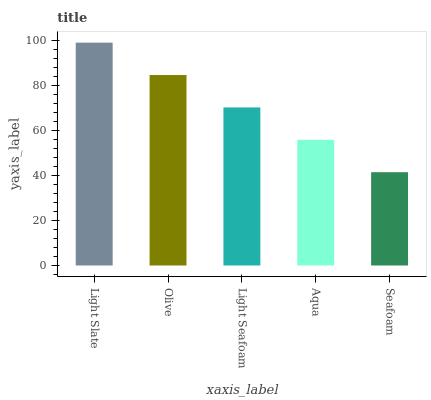Is Seafoam the minimum?
Answer yes or no. Yes. Is Light Slate the maximum?
Answer yes or no. Yes. Is Olive the minimum?
Answer yes or no. No. Is Olive the maximum?
Answer yes or no. No. Is Light Slate greater than Olive?
Answer yes or no. Yes. Is Olive less than Light Slate?
Answer yes or no. Yes. Is Olive greater than Light Slate?
Answer yes or no. No. Is Light Slate less than Olive?
Answer yes or no. No. Is Light Seafoam the high median?
Answer yes or no. Yes. Is Light Seafoam the low median?
Answer yes or no. Yes. Is Aqua the high median?
Answer yes or no. No. Is Seafoam the low median?
Answer yes or no. No. 